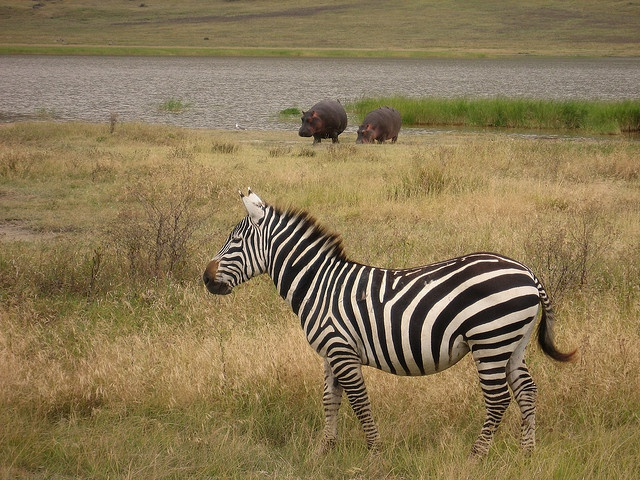Describe the objects in this image and their specific colors. I can see a zebra in gray, black, tan, and olive tones in this image. 